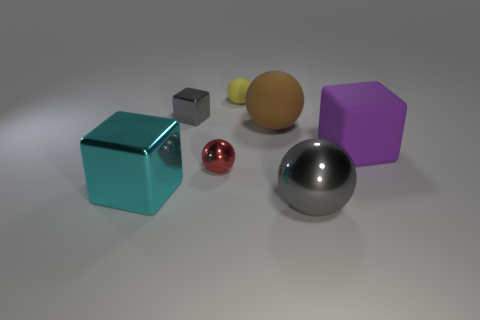Are there fewer tiny yellow objects that are in front of the big brown object than large purple rubber blocks behind the tiny yellow thing?
Give a very brief answer. No. Are the gray ball in front of the tiny matte object and the block on the right side of the tiny metallic block made of the same material?
Offer a terse response. No. What shape is the purple thing?
Ensure brevity in your answer.  Cube. Is the number of metal things that are to the left of the big cyan metal block greater than the number of cyan things on the right side of the big metallic ball?
Provide a short and direct response. No. There is a gray metal thing left of the brown matte sphere; does it have the same shape as the tiny object that is in front of the gray block?
Your answer should be very brief. No. What number of other things are there of the same size as the matte block?
Your response must be concise. 3. The purple rubber thing has what size?
Provide a succinct answer. Large. Do the big block in front of the purple block and the small cube have the same material?
Your answer should be very brief. Yes. What color is the other matte thing that is the same shape as the brown thing?
Give a very brief answer. Yellow. There is a small sphere left of the tiny yellow sphere; is its color the same as the small metal cube?
Ensure brevity in your answer.  No. 